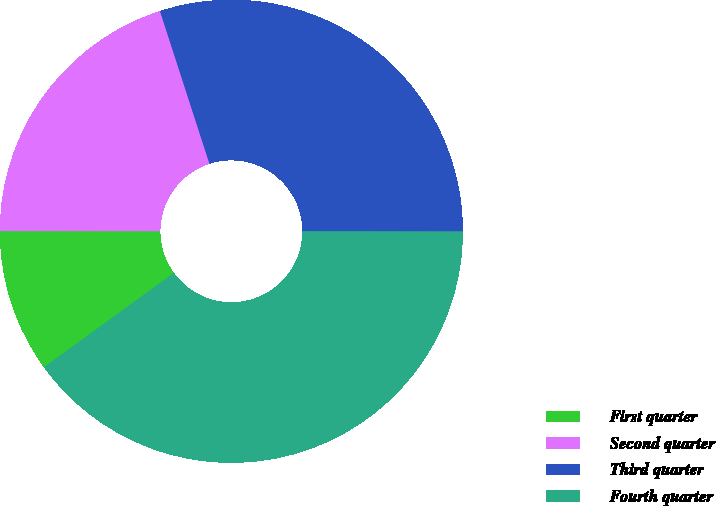<chart> <loc_0><loc_0><loc_500><loc_500><pie_chart><fcel>First quarter<fcel>Second quarter<fcel>Third quarter<fcel>Fourth quarter<nl><fcel>10.0%<fcel>20.0%<fcel>30.0%<fcel>40.0%<nl></chart> 